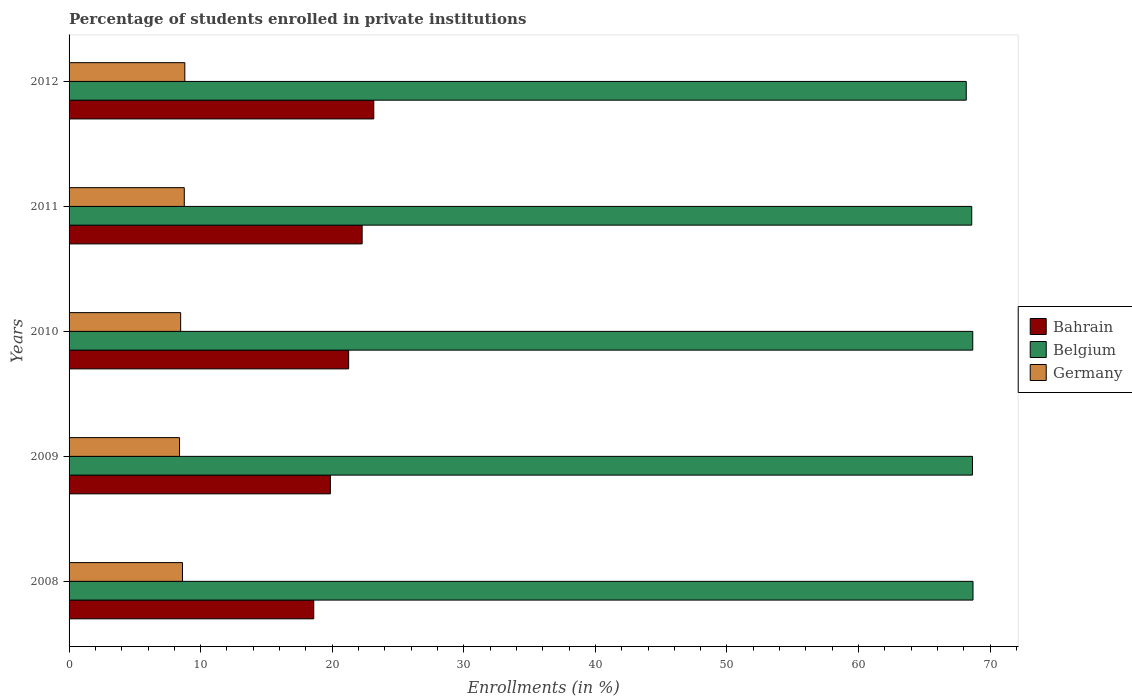How many different coloured bars are there?
Provide a succinct answer. 3. How many groups of bars are there?
Give a very brief answer. 5. How many bars are there on the 1st tick from the top?
Your answer should be compact. 3. What is the label of the 2nd group of bars from the top?
Give a very brief answer. 2011. What is the percentage of trained teachers in Belgium in 2011?
Offer a terse response. 68.6. Across all years, what is the maximum percentage of trained teachers in Bahrain?
Your answer should be very brief. 23.16. Across all years, what is the minimum percentage of trained teachers in Bahrain?
Your answer should be very brief. 18.6. What is the total percentage of trained teachers in Bahrain in the graph?
Your response must be concise. 105.13. What is the difference between the percentage of trained teachers in Bahrain in 2009 and that in 2012?
Ensure brevity in your answer.  -3.3. What is the difference between the percentage of trained teachers in Belgium in 2011 and the percentage of trained teachers in Germany in 2008?
Ensure brevity in your answer.  59.98. What is the average percentage of trained teachers in Germany per year?
Provide a succinct answer. 8.61. In the year 2009, what is the difference between the percentage of trained teachers in Belgium and percentage of trained teachers in Germany?
Offer a terse response. 60.26. In how many years, is the percentage of trained teachers in Germany greater than 66 %?
Provide a succinct answer. 0. What is the ratio of the percentage of trained teachers in Bahrain in 2009 to that in 2011?
Your response must be concise. 0.89. Is the percentage of trained teachers in Germany in 2009 less than that in 2012?
Offer a very short reply. Yes. What is the difference between the highest and the second highest percentage of trained teachers in Belgium?
Your answer should be compact. 0.02. What is the difference between the highest and the lowest percentage of trained teachers in Belgium?
Provide a short and direct response. 0.51. Is the sum of the percentage of trained teachers in Germany in 2010 and 2011 greater than the maximum percentage of trained teachers in Belgium across all years?
Keep it short and to the point. No. What does the 1st bar from the bottom in 2012 represents?
Provide a succinct answer. Bahrain. Is it the case that in every year, the sum of the percentage of trained teachers in Bahrain and percentage of trained teachers in Belgium is greater than the percentage of trained teachers in Germany?
Offer a terse response. Yes. How many years are there in the graph?
Ensure brevity in your answer.  5. What is the difference between two consecutive major ticks on the X-axis?
Your answer should be very brief. 10. Where does the legend appear in the graph?
Your answer should be compact. Center right. How many legend labels are there?
Your response must be concise. 3. What is the title of the graph?
Offer a terse response. Percentage of students enrolled in private institutions. Does "Aruba" appear as one of the legend labels in the graph?
Keep it short and to the point. No. What is the label or title of the X-axis?
Offer a very short reply. Enrollments (in %). What is the label or title of the Y-axis?
Give a very brief answer. Years. What is the Enrollments (in %) of Bahrain in 2008?
Offer a very short reply. 18.6. What is the Enrollments (in %) of Belgium in 2008?
Offer a very short reply. 68.7. What is the Enrollments (in %) in Germany in 2008?
Make the answer very short. 8.62. What is the Enrollments (in %) of Bahrain in 2009?
Keep it short and to the point. 19.86. What is the Enrollments (in %) in Belgium in 2009?
Provide a succinct answer. 68.66. What is the Enrollments (in %) of Germany in 2009?
Make the answer very short. 8.4. What is the Enrollments (in %) of Bahrain in 2010?
Keep it short and to the point. 21.25. What is the Enrollments (in %) in Belgium in 2010?
Your answer should be very brief. 68.68. What is the Enrollments (in %) in Germany in 2010?
Your answer should be compact. 8.48. What is the Enrollments (in %) of Bahrain in 2011?
Provide a short and direct response. 22.27. What is the Enrollments (in %) in Belgium in 2011?
Your answer should be compact. 68.6. What is the Enrollments (in %) in Germany in 2011?
Provide a succinct answer. 8.76. What is the Enrollments (in %) of Bahrain in 2012?
Offer a very short reply. 23.16. What is the Enrollments (in %) of Belgium in 2012?
Ensure brevity in your answer.  68.19. What is the Enrollments (in %) in Germany in 2012?
Your response must be concise. 8.8. Across all years, what is the maximum Enrollments (in %) in Bahrain?
Your answer should be compact. 23.16. Across all years, what is the maximum Enrollments (in %) in Belgium?
Keep it short and to the point. 68.7. Across all years, what is the maximum Enrollments (in %) of Germany?
Offer a very short reply. 8.8. Across all years, what is the minimum Enrollments (in %) in Bahrain?
Your answer should be very brief. 18.6. Across all years, what is the minimum Enrollments (in %) in Belgium?
Your answer should be very brief. 68.19. Across all years, what is the minimum Enrollments (in %) in Germany?
Make the answer very short. 8.4. What is the total Enrollments (in %) in Bahrain in the graph?
Provide a succinct answer. 105.13. What is the total Enrollments (in %) of Belgium in the graph?
Make the answer very short. 342.82. What is the total Enrollments (in %) in Germany in the graph?
Ensure brevity in your answer.  43.05. What is the difference between the Enrollments (in %) of Bahrain in 2008 and that in 2009?
Offer a terse response. -1.26. What is the difference between the Enrollments (in %) of Belgium in 2008 and that in 2009?
Give a very brief answer. 0.04. What is the difference between the Enrollments (in %) of Germany in 2008 and that in 2009?
Keep it short and to the point. 0.22. What is the difference between the Enrollments (in %) in Bahrain in 2008 and that in 2010?
Your answer should be very brief. -2.65. What is the difference between the Enrollments (in %) of Belgium in 2008 and that in 2010?
Your answer should be compact. 0.02. What is the difference between the Enrollments (in %) in Germany in 2008 and that in 2010?
Keep it short and to the point. 0.14. What is the difference between the Enrollments (in %) of Bahrain in 2008 and that in 2011?
Offer a terse response. -3.68. What is the difference between the Enrollments (in %) in Belgium in 2008 and that in 2011?
Offer a terse response. 0.1. What is the difference between the Enrollments (in %) in Germany in 2008 and that in 2011?
Ensure brevity in your answer.  -0.14. What is the difference between the Enrollments (in %) in Bahrain in 2008 and that in 2012?
Provide a succinct answer. -4.56. What is the difference between the Enrollments (in %) in Belgium in 2008 and that in 2012?
Your response must be concise. 0.51. What is the difference between the Enrollments (in %) of Germany in 2008 and that in 2012?
Provide a short and direct response. -0.18. What is the difference between the Enrollments (in %) in Bahrain in 2009 and that in 2010?
Provide a succinct answer. -1.39. What is the difference between the Enrollments (in %) in Belgium in 2009 and that in 2010?
Your answer should be very brief. -0.02. What is the difference between the Enrollments (in %) of Germany in 2009 and that in 2010?
Provide a succinct answer. -0.08. What is the difference between the Enrollments (in %) in Bahrain in 2009 and that in 2011?
Keep it short and to the point. -2.42. What is the difference between the Enrollments (in %) in Belgium in 2009 and that in 2011?
Offer a terse response. 0.05. What is the difference between the Enrollments (in %) in Germany in 2009 and that in 2011?
Provide a succinct answer. -0.36. What is the difference between the Enrollments (in %) of Bahrain in 2009 and that in 2012?
Your response must be concise. -3.3. What is the difference between the Enrollments (in %) of Belgium in 2009 and that in 2012?
Your answer should be compact. 0.47. What is the difference between the Enrollments (in %) of Germany in 2009 and that in 2012?
Your answer should be very brief. -0.4. What is the difference between the Enrollments (in %) in Bahrain in 2010 and that in 2011?
Provide a short and direct response. -1.02. What is the difference between the Enrollments (in %) in Belgium in 2010 and that in 2011?
Your response must be concise. 0.08. What is the difference between the Enrollments (in %) in Germany in 2010 and that in 2011?
Give a very brief answer. -0.28. What is the difference between the Enrollments (in %) in Bahrain in 2010 and that in 2012?
Your response must be concise. -1.91. What is the difference between the Enrollments (in %) of Belgium in 2010 and that in 2012?
Your answer should be very brief. 0.49. What is the difference between the Enrollments (in %) of Germany in 2010 and that in 2012?
Make the answer very short. -0.32. What is the difference between the Enrollments (in %) in Bahrain in 2011 and that in 2012?
Your answer should be compact. -0.89. What is the difference between the Enrollments (in %) of Belgium in 2011 and that in 2012?
Your answer should be compact. 0.42. What is the difference between the Enrollments (in %) in Germany in 2011 and that in 2012?
Offer a very short reply. -0.04. What is the difference between the Enrollments (in %) in Bahrain in 2008 and the Enrollments (in %) in Belgium in 2009?
Provide a succinct answer. -50.06. What is the difference between the Enrollments (in %) of Bahrain in 2008 and the Enrollments (in %) of Germany in 2009?
Give a very brief answer. 10.2. What is the difference between the Enrollments (in %) in Belgium in 2008 and the Enrollments (in %) in Germany in 2009?
Your answer should be very brief. 60.3. What is the difference between the Enrollments (in %) of Bahrain in 2008 and the Enrollments (in %) of Belgium in 2010?
Provide a succinct answer. -50.08. What is the difference between the Enrollments (in %) of Bahrain in 2008 and the Enrollments (in %) of Germany in 2010?
Your answer should be compact. 10.12. What is the difference between the Enrollments (in %) of Belgium in 2008 and the Enrollments (in %) of Germany in 2010?
Your response must be concise. 60.22. What is the difference between the Enrollments (in %) in Bahrain in 2008 and the Enrollments (in %) in Belgium in 2011?
Make the answer very short. -50.01. What is the difference between the Enrollments (in %) of Bahrain in 2008 and the Enrollments (in %) of Germany in 2011?
Your answer should be very brief. 9.84. What is the difference between the Enrollments (in %) of Belgium in 2008 and the Enrollments (in %) of Germany in 2011?
Make the answer very short. 59.94. What is the difference between the Enrollments (in %) in Bahrain in 2008 and the Enrollments (in %) in Belgium in 2012?
Provide a short and direct response. -49.59. What is the difference between the Enrollments (in %) of Bahrain in 2008 and the Enrollments (in %) of Germany in 2012?
Your response must be concise. 9.8. What is the difference between the Enrollments (in %) of Belgium in 2008 and the Enrollments (in %) of Germany in 2012?
Provide a succinct answer. 59.9. What is the difference between the Enrollments (in %) of Bahrain in 2009 and the Enrollments (in %) of Belgium in 2010?
Your answer should be very brief. -48.82. What is the difference between the Enrollments (in %) of Bahrain in 2009 and the Enrollments (in %) of Germany in 2010?
Ensure brevity in your answer.  11.38. What is the difference between the Enrollments (in %) in Belgium in 2009 and the Enrollments (in %) in Germany in 2010?
Give a very brief answer. 60.18. What is the difference between the Enrollments (in %) in Bahrain in 2009 and the Enrollments (in %) in Belgium in 2011?
Keep it short and to the point. -48.74. What is the difference between the Enrollments (in %) of Bahrain in 2009 and the Enrollments (in %) of Germany in 2011?
Keep it short and to the point. 11.1. What is the difference between the Enrollments (in %) in Belgium in 2009 and the Enrollments (in %) in Germany in 2011?
Your answer should be compact. 59.9. What is the difference between the Enrollments (in %) in Bahrain in 2009 and the Enrollments (in %) in Belgium in 2012?
Your answer should be very brief. -48.33. What is the difference between the Enrollments (in %) of Bahrain in 2009 and the Enrollments (in %) of Germany in 2012?
Ensure brevity in your answer.  11.06. What is the difference between the Enrollments (in %) of Belgium in 2009 and the Enrollments (in %) of Germany in 2012?
Your answer should be very brief. 59.86. What is the difference between the Enrollments (in %) of Bahrain in 2010 and the Enrollments (in %) of Belgium in 2011?
Your answer should be very brief. -47.35. What is the difference between the Enrollments (in %) in Bahrain in 2010 and the Enrollments (in %) in Germany in 2011?
Ensure brevity in your answer.  12.49. What is the difference between the Enrollments (in %) of Belgium in 2010 and the Enrollments (in %) of Germany in 2011?
Offer a very short reply. 59.92. What is the difference between the Enrollments (in %) of Bahrain in 2010 and the Enrollments (in %) of Belgium in 2012?
Keep it short and to the point. -46.94. What is the difference between the Enrollments (in %) in Bahrain in 2010 and the Enrollments (in %) in Germany in 2012?
Provide a succinct answer. 12.45. What is the difference between the Enrollments (in %) of Belgium in 2010 and the Enrollments (in %) of Germany in 2012?
Make the answer very short. 59.88. What is the difference between the Enrollments (in %) of Bahrain in 2011 and the Enrollments (in %) of Belgium in 2012?
Give a very brief answer. -45.91. What is the difference between the Enrollments (in %) in Bahrain in 2011 and the Enrollments (in %) in Germany in 2012?
Provide a succinct answer. 13.47. What is the difference between the Enrollments (in %) in Belgium in 2011 and the Enrollments (in %) in Germany in 2012?
Provide a succinct answer. 59.8. What is the average Enrollments (in %) in Bahrain per year?
Keep it short and to the point. 21.03. What is the average Enrollments (in %) in Belgium per year?
Your answer should be very brief. 68.56. What is the average Enrollments (in %) of Germany per year?
Keep it short and to the point. 8.61. In the year 2008, what is the difference between the Enrollments (in %) of Bahrain and Enrollments (in %) of Belgium?
Offer a terse response. -50.1. In the year 2008, what is the difference between the Enrollments (in %) of Bahrain and Enrollments (in %) of Germany?
Provide a succinct answer. 9.98. In the year 2008, what is the difference between the Enrollments (in %) in Belgium and Enrollments (in %) in Germany?
Your response must be concise. 60.08. In the year 2009, what is the difference between the Enrollments (in %) in Bahrain and Enrollments (in %) in Belgium?
Offer a terse response. -48.8. In the year 2009, what is the difference between the Enrollments (in %) in Bahrain and Enrollments (in %) in Germany?
Provide a succinct answer. 11.46. In the year 2009, what is the difference between the Enrollments (in %) in Belgium and Enrollments (in %) in Germany?
Your answer should be very brief. 60.26. In the year 2010, what is the difference between the Enrollments (in %) in Bahrain and Enrollments (in %) in Belgium?
Make the answer very short. -47.43. In the year 2010, what is the difference between the Enrollments (in %) in Bahrain and Enrollments (in %) in Germany?
Your answer should be compact. 12.77. In the year 2010, what is the difference between the Enrollments (in %) in Belgium and Enrollments (in %) in Germany?
Give a very brief answer. 60.2. In the year 2011, what is the difference between the Enrollments (in %) of Bahrain and Enrollments (in %) of Belgium?
Your answer should be compact. -46.33. In the year 2011, what is the difference between the Enrollments (in %) of Bahrain and Enrollments (in %) of Germany?
Ensure brevity in your answer.  13.52. In the year 2011, what is the difference between the Enrollments (in %) in Belgium and Enrollments (in %) in Germany?
Your answer should be compact. 59.85. In the year 2012, what is the difference between the Enrollments (in %) of Bahrain and Enrollments (in %) of Belgium?
Give a very brief answer. -45.03. In the year 2012, what is the difference between the Enrollments (in %) of Bahrain and Enrollments (in %) of Germany?
Offer a terse response. 14.36. In the year 2012, what is the difference between the Enrollments (in %) of Belgium and Enrollments (in %) of Germany?
Keep it short and to the point. 59.39. What is the ratio of the Enrollments (in %) of Bahrain in 2008 to that in 2009?
Give a very brief answer. 0.94. What is the ratio of the Enrollments (in %) in Germany in 2008 to that in 2009?
Your answer should be compact. 1.03. What is the ratio of the Enrollments (in %) of Bahrain in 2008 to that in 2010?
Keep it short and to the point. 0.88. What is the ratio of the Enrollments (in %) in Germany in 2008 to that in 2010?
Offer a very short reply. 1.02. What is the ratio of the Enrollments (in %) of Bahrain in 2008 to that in 2011?
Your answer should be very brief. 0.83. What is the ratio of the Enrollments (in %) in Germany in 2008 to that in 2011?
Give a very brief answer. 0.98. What is the ratio of the Enrollments (in %) of Bahrain in 2008 to that in 2012?
Your answer should be very brief. 0.8. What is the ratio of the Enrollments (in %) of Belgium in 2008 to that in 2012?
Your answer should be compact. 1.01. What is the ratio of the Enrollments (in %) of Germany in 2008 to that in 2012?
Make the answer very short. 0.98. What is the ratio of the Enrollments (in %) of Bahrain in 2009 to that in 2010?
Offer a very short reply. 0.93. What is the ratio of the Enrollments (in %) in Belgium in 2009 to that in 2010?
Your answer should be very brief. 1. What is the ratio of the Enrollments (in %) of Germany in 2009 to that in 2010?
Provide a succinct answer. 0.99. What is the ratio of the Enrollments (in %) in Bahrain in 2009 to that in 2011?
Make the answer very short. 0.89. What is the ratio of the Enrollments (in %) of Germany in 2009 to that in 2011?
Your answer should be compact. 0.96. What is the ratio of the Enrollments (in %) of Bahrain in 2009 to that in 2012?
Your response must be concise. 0.86. What is the ratio of the Enrollments (in %) of Belgium in 2009 to that in 2012?
Provide a short and direct response. 1.01. What is the ratio of the Enrollments (in %) in Germany in 2009 to that in 2012?
Give a very brief answer. 0.95. What is the ratio of the Enrollments (in %) of Bahrain in 2010 to that in 2011?
Make the answer very short. 0.95. What is the ratio of the Enrollments (in %) of Germany in 2010 to that in 2011?
Make the answer very short. 0.97. What is the ratio of the Enrollments (in %) of Bahrain in 2010 to that in 2012?
Your answer should be very brief. 0.92. What is the ratio of the Enrollments (in %) of Belgium in 2010 to that in 2012?
Ensure brevity in your answer.  1.01. What is the ratio of the Enrollments (in %) in Germany in 2010 to that in 2012?
Offer a very short reply. 0.96. What is the ratio of the Enrollments (in %) in Bahrain in 2011 to that in 2012?
Ensure brevity in your answer.  0.96. What is the ratio of the Enrollments (in %) of Belgium in 2011 to that in 2012?
Your answer should be very brief. 1.01. What is the ratio of the Enrollments (in %) of Germany in 2011 to that in 2012?
Provide a short and direct response. 1. What is the difference between the highest and the second highest Enrollments (in %) in Bahrain?
Give a very brief answer. 0.89. What is the difference between the highest and the second highest Enrollments (in %) of Belgium?
Offer a very short reply. 0.02. What is the difference between the highest and the second highest Enrollments (in %) in Germany?
Make the answer very short. 0.04. What is the difference between the highest and the lowest Enrollments (in %) in Bahrain?
Offer a terse response. 4.56. What is the difference between the highest and the lowest Enrollments (in %) of Belgium?
Ensure brevity in your answer.  0.51. What is the difference between the highest and the lowest Enrollments (in %) of Germany?
Make the answer very short. 0.4. 